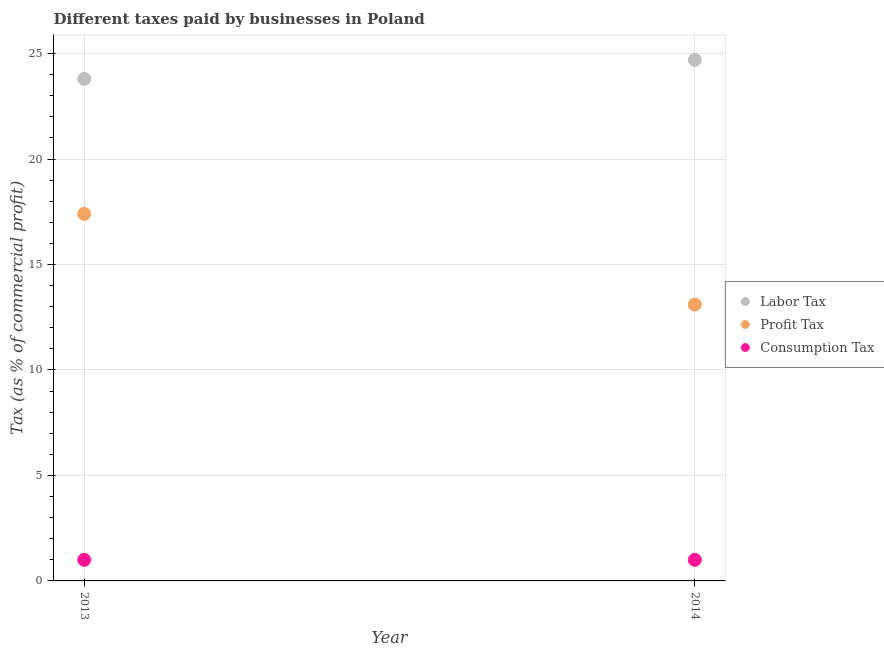Is the number of dotlines equal to the number of legend labels?
Make the answer very short. Yes. What is the percentage of profit tax in 2014?
Your response must be concise. 13.1. Across all years, what is the maximum percentage of consumption tax?
Provide a succinct answer. 1. Across all years, what is the minimum percentage of labor tax?
Offer a terse response. 23.8. In which year was the percentage of profit tax maximum?
Provide a short and direct response. 2013. In which year was the percentage of profit tax minimum?
Your response must be concise. 2014. What is the total percentage of profit tax in the graph?
Give a very brief answer. 30.5. What is the difference between the percentage of labor tax in 2013 and that in 2014?
Offer a terse response. -0.9. What is the average percentage of profit tax per year?
Make the answer very short. 15.25. In the year 2014, what is the difference between the percentage of consumption tax and percentage of labor tax?
Offer a terse response. -23.7. In how many years, is the percentage of profit tax greater than 4 %?
Make the answer very short. 2. What is the ratio of the percentage of profit tax in 2013 to that in 2014?
Your answer should be compact. 1.33. Is the percentage of profit tax in 2013 less than that in 2014?
Your answer should be very brief. No. In how many years, is the percentage of labor tax greater than the average percentage of labor tax taken over all years?
Offer a very short reply. 1. Is the percentage of profit tax strictly less than the percentage of labor tax over the years?
Ensure brevity in your answer.  Yes. How many years are there in the graph?
Your answer should be compact. 2. Does the graph contain grids?
Offer a terse response. Yes. Where does the legend appear in the graph?
Provide a short and direct response. Center right. How many legend labels are there?
Offer a very short reply. 3. What is the title of the graph?
Provide a short and direct response. Different taxes paid by businesses in Poland. What is the label or title of the Y-axis?
Offer a very short reply. Tax (as % of commercial profit). What is the Tax (as % of commercial profit) in Labor Tax in 2013?
Your response must be concise. 23.8. What is the Tax (as % of commercial profit) in Labor Tax in 2014?
Keep it short and to the point. 24.7. What is the Tax (as % of commercial profit) of Consumption Tax in 2014?
Your response must be concise. 1. Across all years, what is the maximum Tax (as % of commercial profit) of Labor Tax?
Your answer should be compact. 24.7. Across all years, what is the maximum Tax (as % of commercial profit) in Profit Tax?
Make the answer very short. 17.4. Across all years, what is the minimum Tax (as % of commercial profit) in Labor Tax?
Provide a succinct answer. 23.8. Across all years, what is the minimum Tax (as % of commercial profit) of Profit Tax?
Offer a very short reply. 13.1. Across all years, what is the minimum Tax (as % of commercial profit) of Consumption Tax?
Give a very brief answer. 1. What is the total Tax (as % of commercial profit) in Labor Tax in the graph?
Offer a very short reply. 48.5. What is the total Tax (as % of commercial profit) of Profit Tax in the graph?
Offer a very short reply. 30.5. What is the total Tax (as % of commercial profit) in Consumption Tax in the graph?
Provide a short and direct response. 2. What is the difference between the Tax (as % of commercial profit) of Labor Tax in 2013 and the Tax (as % of commercial profit) of Profit Tax in 2014?
Keep it short and to the point. 10.7. What is the difference between the Tax (as % of commercial profit) in Labor Tax in 2013 and the Tax (as % of commercial profit) in Consumption Tax in 2014?
Give a very brief answer. 22.8. What is the difference between the Tax (as % of commercial profit) of Profit Tax in 2013 and the Tax (as % of commercial profit) of Consumption Tax in 2014?
Your answer should be very brief. 16.4. What is the average Tax (as % of commercial profit) in Labor Tax per year?
Your response must be concise. 24.25. What is the average Tax (as % of commercial profit) of Profit Tax per year?
Make the answer very short. 15.25. In the year 2013, what is the difference between the Tax (as % of commercial profit) in Labor Tax and Tax (as % of commercial profit) in Consumption Tax?
Your answer should be compact. 22.8. In the year 2013, what is the difference between the Tax (as % of commercial profit) in Profit Tax and Tax (as % of commercial profit) in Consumption Tax?
Your answer should be compact. 16.4. In the year 2014, what is the difference between the Tax (as % of commercial profit) in Labor Tax and Tax (as % of commercial profit) in Profit Tax?
Make the answer very short. 11.6. In the year 2014, what is the difference between the Tax (as % of commercial profit) of Labor Tax and Tax (as % of commercial profit) of Consumption Tax?
Make the answer very short. 23.7. What is the ratio of the Tax (as % of commercial profit) of Labor Tax in 2013 to that in 2014?
Your response must be concise. 0.96. What is the ratio of the Tax (as % of commercial profit) in Profit Tax in 2013 to that in 2014?
Provide a short and direct response. 1.33. What is the difference between the highest and the lowest Tax (as % of commercial profit) in Labor Tax?
Your answer should be very brief. 0.9. What is the difference between the highest and the lowest Tax (as % of commercial profit) of Profit Tax?
Give a very brief answer. 4.3. What is the difference between the highest and the lowest Tax (as % of commercial profit) in Consumption Tax?
Give a very brief answer. 0. 